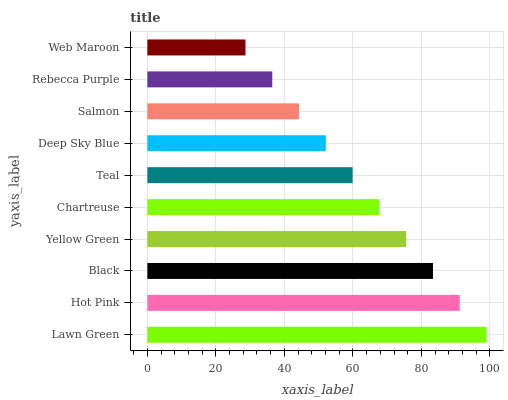Is Web Maroon the minimum?
Answer yes or no. Yes. Is Lawn Green the maximum?
Answer yes or no. Yes. Is Hot Pink the minimum?
Answer yes or no. No. Is Hot Pink the maximum?
Answer yes or no. No. Is Lawn Green greater than Hot Pink?
Answer yes or no. Yes. Is Hot Pink less than Lawn Green?
Answer yes or no. Yes. Is Hot Pink greater than Lawn Green?
Answer yes or no. No. Is Lawn Green less than Hot Pink?
Answer yes or no. No. Is Chartreuse the high median?
Answer yes or no. Yes. Is Teal the low median?
Answer yes or no. Yes. Is Rebecca Purple the high median?
Answer yes or no. No. Is Deep Sky Blue the low median?
Answer yes or no. No. 